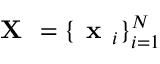<formula> <loc_0><loc_0><loc_500><loc_500>X = \{ x _ { i } \} _ { i = 1 } ^ { N }</formula> 